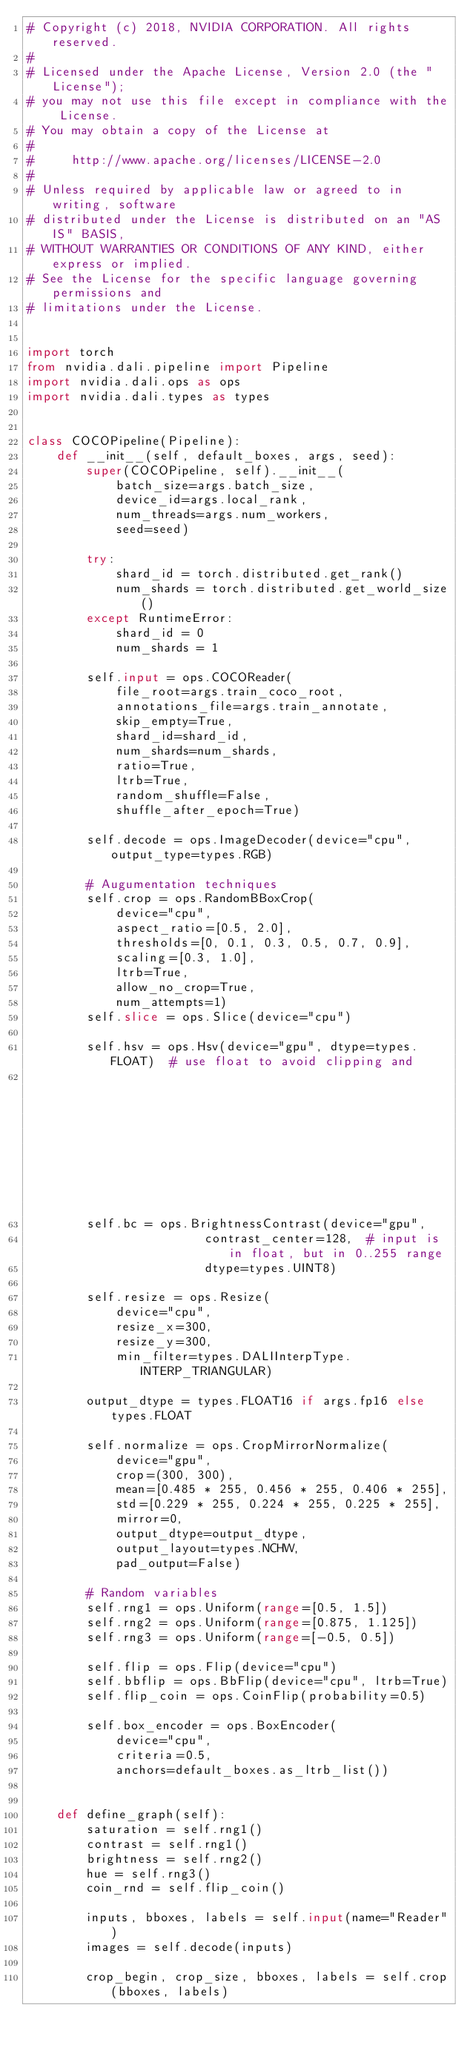Convert code to text. <code><loc_0><loc_0><loc_500><loc_500><_Python_># Copyright (c) 2018, NVIDIA CORPORATION. All rights reserved.
#
# Licensed under the Apache License, Version 2.0 (the "License");
# you may not use this file except in compliance with the License.
# You may obtain a copy of the License at
#
#     http://www.apache.org/licenses/LICENSE-2.0
#
# Unless required by applicable law or agreed to in writing, software
# distributed under the License is distributed on an "AS IS" BASIS,
# WITHOUT WARRANTIES OR CONDITIONS OF ANY KIND, either express or implied.
# See the License for the specific language governing permissions and
# limitations under the License.


import torch
from nvidia.dali.pipeline import Pipeline
import nvidia.dali.ops as ops
import nvidia.dali.types as types


class COCOPipeline(Pipeline):
    def __init__(self, default_boxes, args, seed):
        super(COCOPipeline, self).__init__(
            batch_size=args.batch_size,
            device_id=args.local_rank,
            num_threads=args.num_workers,
            seed=seed)

        try:
            shard_id = torch.distributed.get_rank()
            num_shards = torch.distributed.get_world_size()
        except RuntimeError:
            shard_id = 0
            num_shards = 1

        self.input = ops.COCOReader(
            file_root=args.train_coco_root,
            annotations_file=args.train_annotate,
            skip_empty=True,
            shard_id=shard_id,
            num_shards=num_shards,
            ratio=True,
            ltrb=True,
            random_shuffle=False,
            shuffle_after_epoch=True)

        self.decode = ops.ImageDecoder(device="cpu", output_type=types.RGB)

        # Augumentation techniques
        self.crop = ops.RandomBBoxCrop(
            device="cpu",
            aspect_ratio=[0.5, 2.0],
            thresholds=[0, 0.1, 0.3, 0.5, 0.7, 0.9],
            scaling=[0.3, 1.0],
            ltrb=True,
            allow_no_crop=True,
            num_attempts=1)
        self.slice = ops.Slice(device="cpu")

        self.hsv = ops.Hsv(device="gpu", dtype=types.FLOAT)  # use float to avoid clipping and
                                                             # quantizing the intermediate result
        self.bc = ops.BrightnessContrast(device="gpu",
                        contrast_center=128,  # input is in float, but in 0..255 range
                        dtype=types.UINT8)

        self.resize = ops.Resize(
            device="cpu",
            resize_x=300,
            resize_y=300,
            min_filter=types.DALIInterpType.INTERP_TRIANGULAR)

        output_dtype = types.FLOAT16 if args.fp16 else types.FLOAT

        self.normalize = ops.CropMirrorNormalize(
            device="gpu",
            crop=(300, 300),
            mean=[0.485 * 255, 0.456 * 255, 0.406 * 255],
            std=[0.229 * 255, 0.224 * 255, 0.225 * 255],
            mirror=0,
            output_dtype=output_dtype,
            output_layout=types.NCHW,
            pad_output=False)

        # Random variables
        self.rng1 = ops.Uniform(range=[0.5, 1.5])
        self.rng2 = ops.Uniform(range=[0.875, 1.125])
        self.rng3 = ops.Uniform(range=[-0.5, 0.5])

        self.flip = ops.Flip(device="cpu")
        self.bbflip = ops.BbFlip(device="cpu", ltrb=True)
        self.flip_coin = ops.CoinFlip(probability=0.5)

        self.box_encoder = ops.BoxEncoder(
            device="cpu",
            criteria=0.5,
            anchors=default_boxes.as_ltrb_list())


    def define_graph(self):
        saturation = self.rng1()
        contrast = self.rng1()
        brightness = self.rng2()
        hue = self.rng3()
        coin_rnd = self.flip_coin()

        inputs, bboxes, labels = self.input(name="Reader")
        images = self.decode(inputs)

        crop_begin, crop_size, bboxes, labels = self.crop(bboxes, labels)</code> 